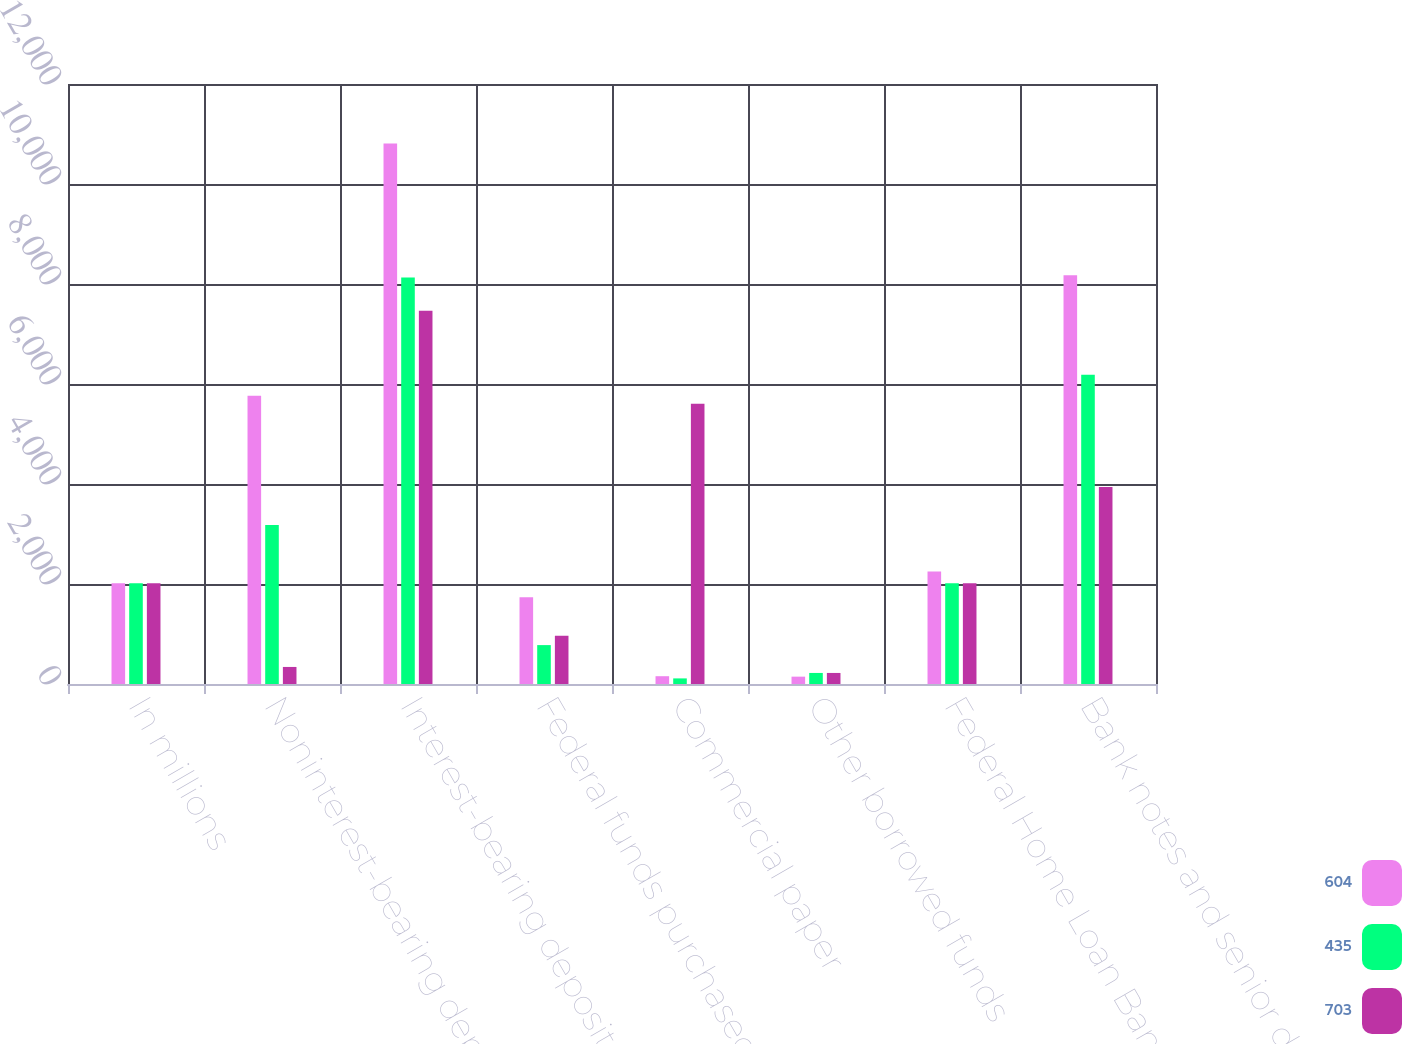<chart> <loc_0><loc_0><loc_500><loc_500><stacked_bar_chart><ecel><fcel>In millions<fcel>Noninterest-bearing deposits<fcel>Interest-bearing deposits<fcel>Federal funds purchased and<fcel>Commercial paper<fcel>Other borrowed funds<fcel>Federal Home Loan Bank<fcel>Bank notes and senior debt<nl><fcel>604<fcel>2015<fcel>5765<fcel>10812<fcel>1733<fcel>156<fcel>147<fcel>2250<fcel>8173<nl><fcel>435<fcel>2014<fcel>3182<fcel>8130<fcel>778<fcel>112<fcel>221<fcel>2014.5<fcel>6184<nl><fcel>703<fcel>2013<fcel>341<fcel>7463<fcel>965<fcel>5607<fcel>221<fcel>2014.5<fcel>3938<nl></chart> 